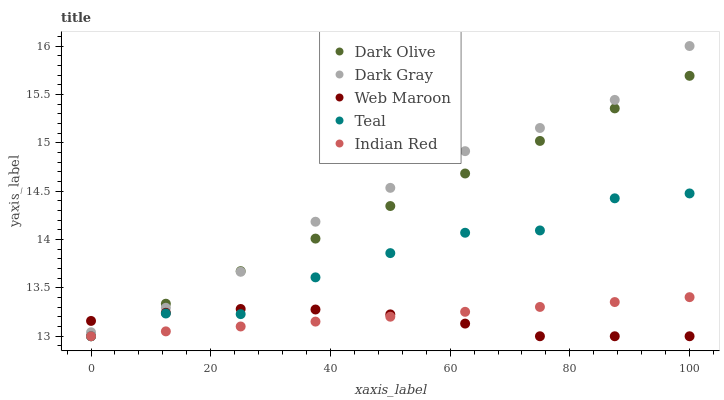Does Web Maroon have the minimum area under the curve?
Answer yes or no. Yes. Does Dark Gray have the maximum area under the curve?
Answer yes or no. Yes. Does Dark Olive have the minimum area under the curve?
Answer yes or no. No. Does Dark Olive have the maximum area under the curve?
Answer yes or no. No. Is Indian Red the smoothest?
Answer yes or no. Yes. Is Teal the roughest?
Answer yes or no. Yes. Is Dark Olive the smoothest?
Answer yes or no. No. Is Dark Olive the roughest?
Answer yes or no. No. Does Dark Olive have the lowest value?
Answer yes or no. Yes. Does Dark Gray have the highest value?
Answer yes or no. Yes. Does Dark Olive have the highest value?
Answer yes or no. No. Is Indian Red less than Dark Gray?
Answer yes or no. Yes. Is Dark Gray greater than Indian Red?
Answer yes or no. Yes. Does Dark Gray intersect Dark Olive?
Answer yes or no. Yes. Is Dark Gray less than Dark Olive?
Answer yes or no. No. Is Dark Gray greater than Dark Olive?
Answer yes or no. No. Does Indian Red intersect Dark Gray?
Answer yes or no. No. 